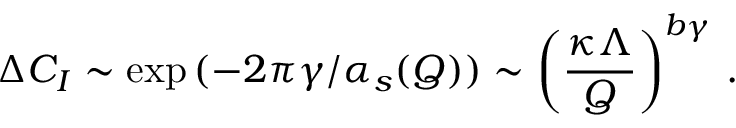Convert formula to latex. <formula><loc_0><loc_0><loc_500><loc_500>\Delta C _ { I } \sim \exp { ( - 2 \pi \gamma / \alpha _ { s } ( Q ) ) } \sim \left ( \frac { \kappa \Lambda } { Q } \right ) ^ { b \gamma } \, .</formula> 